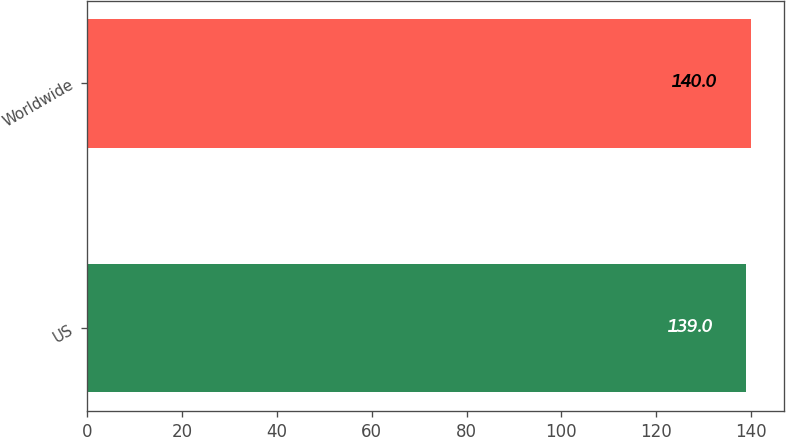<chart> <loc_0><loc_0><loc_500><loc_500><bar_chart><fcel>US<fcel>Worldwide<nl><fcel>139<fcel>140<nl></chart> 